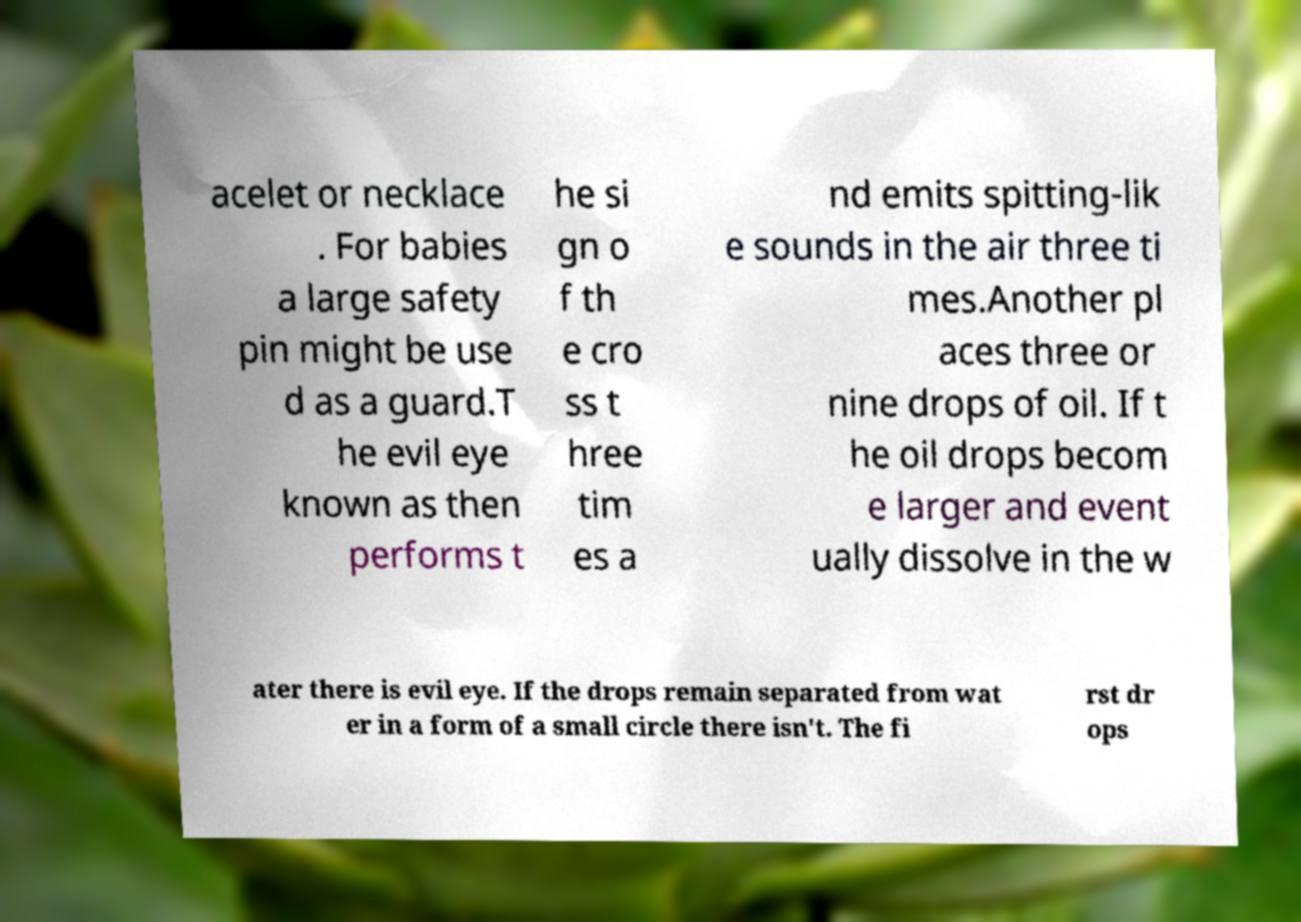There's text embedded in this image that I need extracted. Can you transcribe it verbatim? acelet or necklace . For babies a large safety pin might be use d as a guard.T he evil eye known as then performs t he si gn o f th e cro ss t hree tim es a nd emits spitting-lik e sounds in the air three ti mes.Another pl aces three or nine drops of oil. If t he oil drops becom e larger and event ually dissolve in the w ater there is evil eye. If the drops remain separated from wat er in a form of a small circle there isn't. The fi rst dr ops 